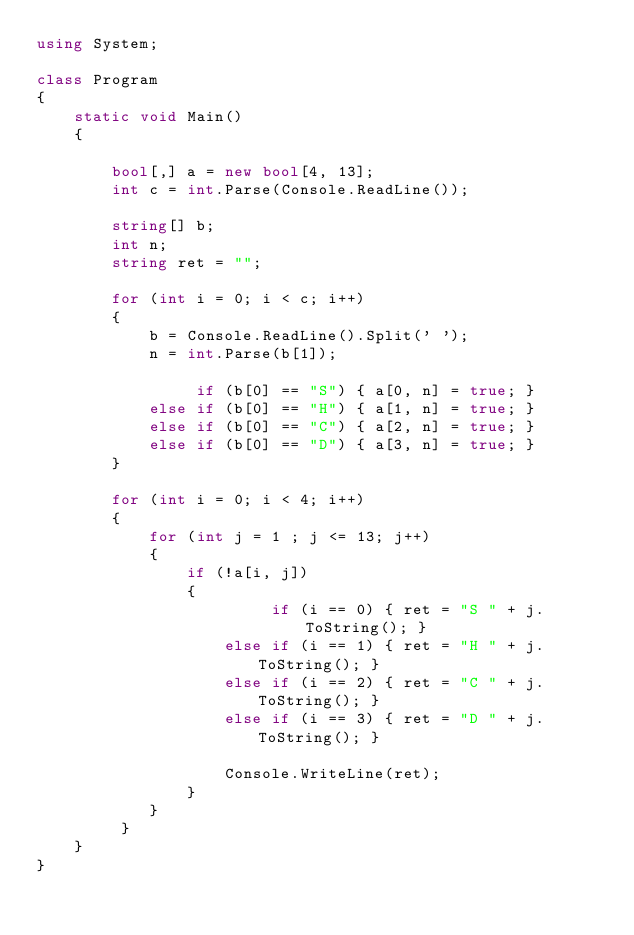Convert code to text. <code><loc_0><loc_0><loc_500><loc_500><_C#_>using System;

class Program
{
    static void Main()
    {
        
        bool[,] a = new bool[4, 13];
        int c = int.Parse(Console.ReadLine());
        
        string[] b;
        int n;
        string ret = "";
        
        for (int i = 0; i < c; i++)
        {
            b = Console.ReadLine().Split(' ');
            n = int.Parse(b[1]);
            
                 if (b[0] == "S") { a[0, n] = true; }
            else if (b[0] == "H") { a[1, n] = true; }
            else if (b[0] == "C") { a[2, n] = true; }
            else if (b[0] == "D") { a[3, n] = true; }
        }
        
        for (int i = 0; i < 4; i++)
        {
            for (int j = 1 ; j <= 13; j++)
            {
                if (!a[i, j]) 
                {
                         if (i == 0) { ret = "S " + j.ToString(); }
                    else if (i == 1) { ret = "H " + j.ToString(); }
                    else if (i == 2) { ret = "C " + j.ToString(); }
                    else if (i == 3) { ret = "D " + j.ToString(); }
                    
                    Console.WriteLine(ret);
                }
            }
         }
    }
}

</code> 